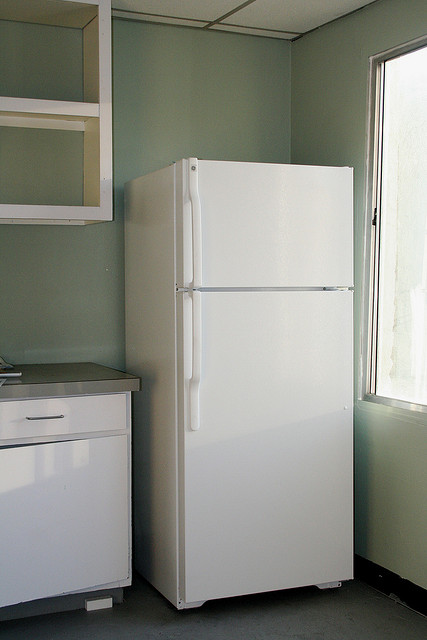<image>Are the cabinets installed yet? I am not sure if the cabinets are installed yet. It could be yes or no. Are the cabinets installed yet? I don't know if the cabinets are installed yet. It is possible that they are not installed yet, but I am not certain. 